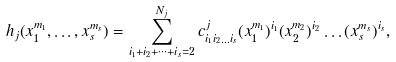Convert formula to latex. <formula><loc_0><loc_0><loc_500><loc_500>h _ { j } ( x _ { 1 } ^ { m _ { 1 } } , \dots , x _ { s } ^ { m _ { s } } ) = \sum _ { i _ { 1 } + i _ { 2 } + \dots + i _ { s } = 2 } ^ { N _ { j } } c _ { i _ { 1 } i _ { 2 } \dots i _ { s } } ^ { j } ( x _ { 1 } ^ { m _ { 1 } } ) ^ { i _ { 1 } } ( x _ { 2 } ^ { m _ { 2 } } ) ^ { i _ { 2 } } \dots ( x _ { s } ^ { m _ { s } } ) ^ { i _ { s } } ,</formula> 